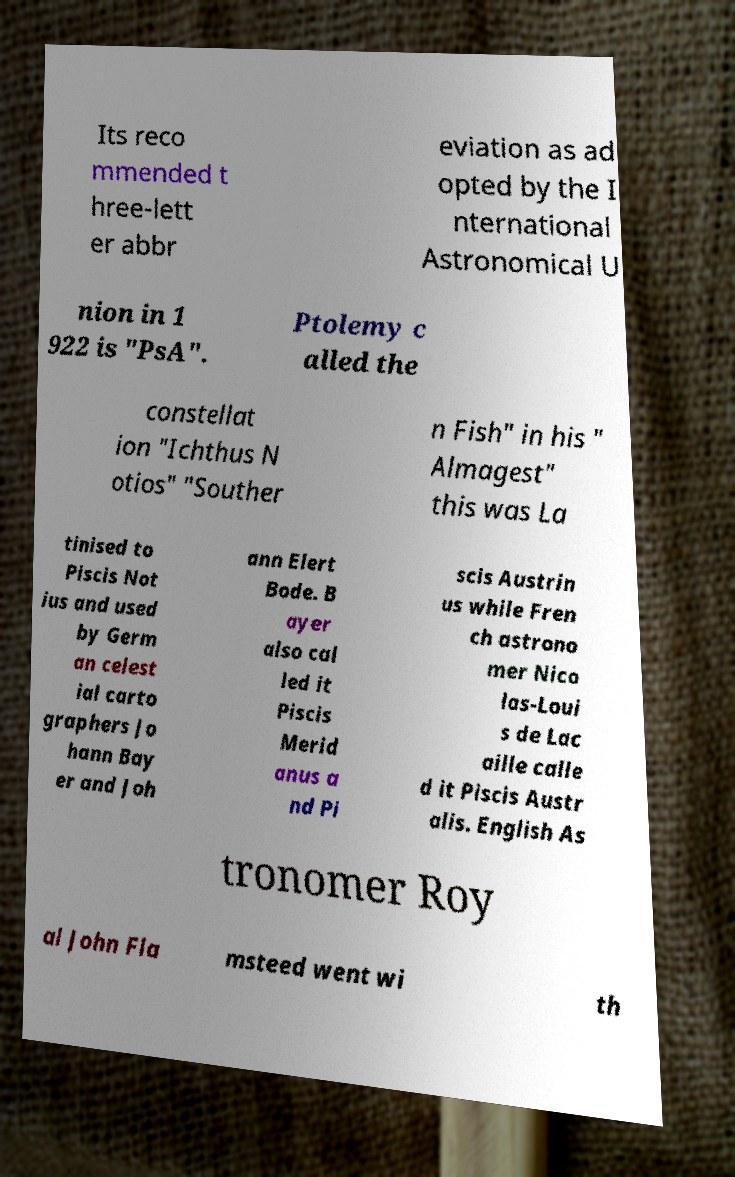Could you assist in decoding the text presented in this image and type it out clearly? Its reco mmended t hree-lett er abbr eviation as ad opted by the I nternational Astronomical U nion in 1 922 is "PsA". Ptolemy c alled the constellat ion "Ichthus N otios" "Souther n Fish" in his " Almagest" this was La tinised to Piscis Not ius and used by Germ an celest ial carto graphers Jo hann Bay er and Joh ann Elert Bode. B ayer also cal led it Piscis Merid anus a nd Pi scis Austrin us while Fren ch astrono mer Nico las-Loui s de Lac aille calle d it Piscis Austr alis. English As tronomer Roy al John Fla msteed went wi th 